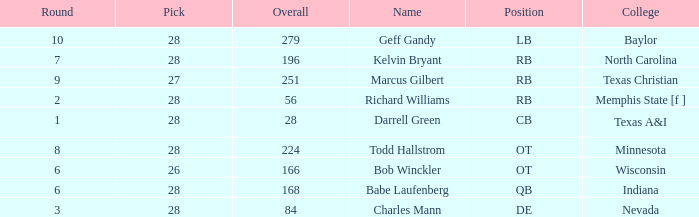What is the highest pick of the player from texas a&i with an overall less than 28? None. 